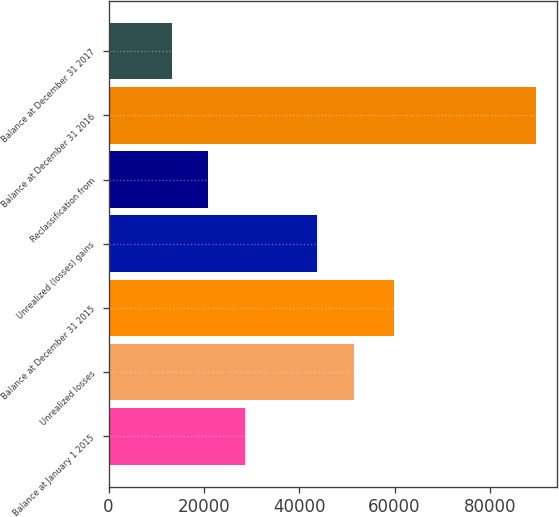<chart> <loc_0><loc_0><loc_500><loc_500><bar_chart><fcel>Balance at January 1 2015<fcel>Unrealized losses<fcel>Balance at December 31 2015<fcel>Unrealized (losses) gains<fcel>Reclassification from<fcel>Balance at December 31 2016<fcel>Balance at December 31 2017<nl><fcel>28516.6<fcel>51465.8<fcel>59826<fcel>43825<fcel>20875.8<fcel>89643<fcel>13235<nl></chart> 